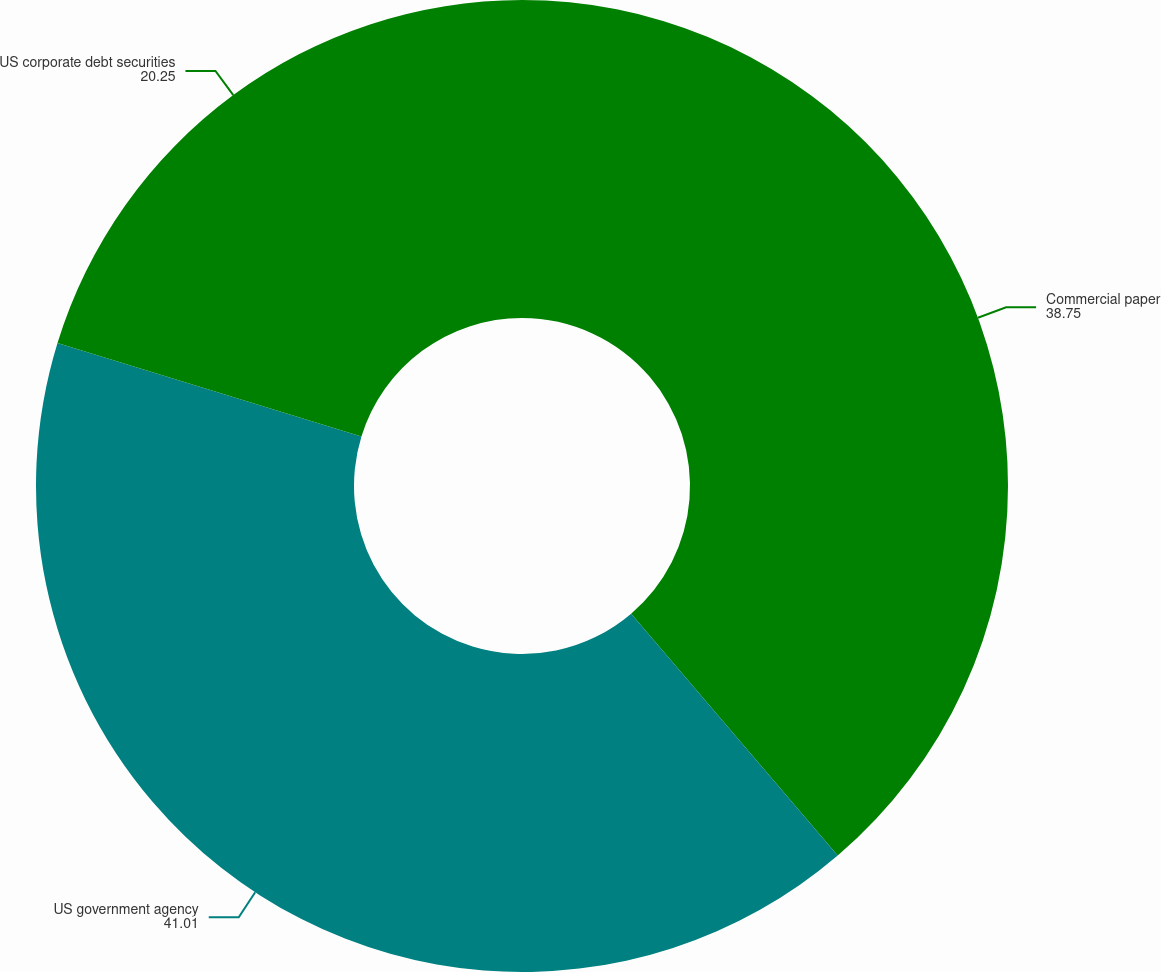<chart> <loc_0><loc_0><loc_500><loc_500><pie_chart><fcel>Commercial paper<fcel>US government agency<fcel>US corporate debt securities<nl><fcel>38.75%<fcel>41.01%<fcel>20.25%<nl></chart> 